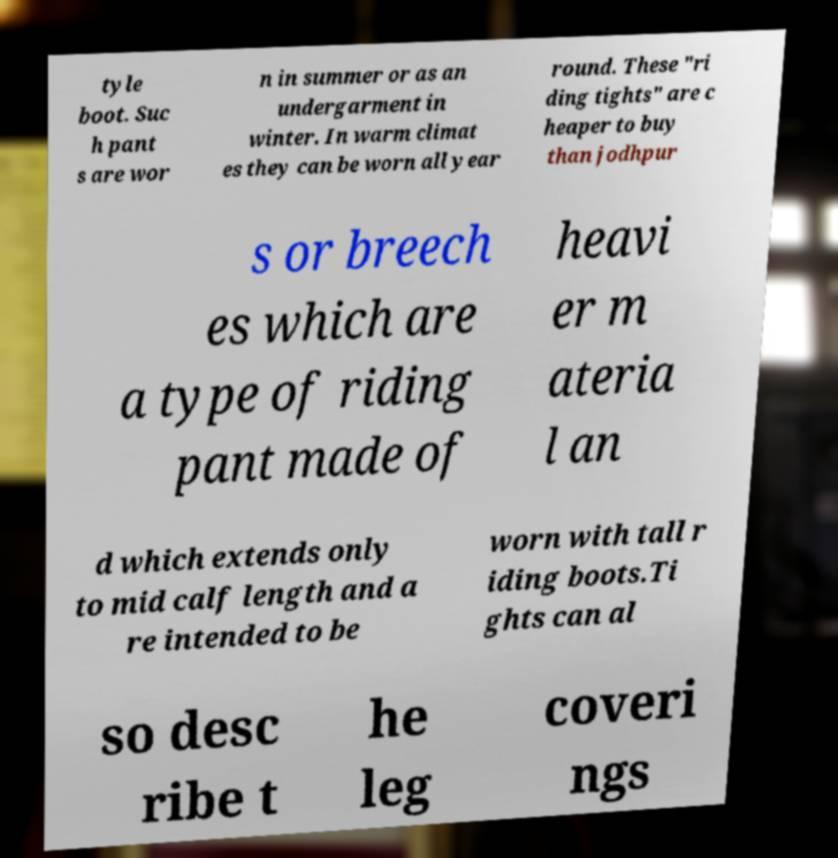Could you assist in decoding the text presented in this image and type it out clearly? tyle boot. Suc h pant s are wor n in summer or as an undergarment in winter. In warm climat es they can be worn all year round. These "ri ding tights" are c heaper to buy than jodhpur s or breech es which are a type of riding pant made of heavi er m ateria l an d which extends only to mid calf length and a re intended to be worn with tall r iding boots.Ti ghts can al so desc ribe t he leg coveri ngs 